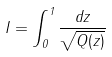Convert formula to latex. <formula><loc_0><loc_0><loc_500><loc_500>I = \int _ { 0 } ^ { 1 } \frac { d z } { \sqrt { Q ( z ) } }</formula> 